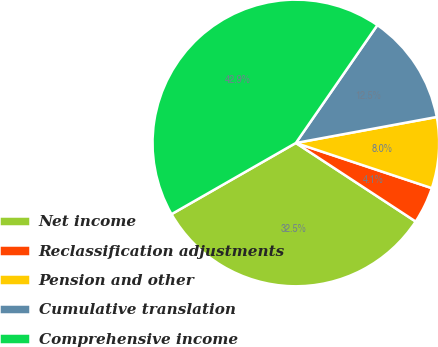Convert chart. <chart><loc_0><loc_0><loc_500><loc_500><pie_chart><fcel>Net income<fcel>Reclassification adjustments<fcel>Pension and other<fcel>Cumulative translation<fcel>Comprehensive income<nl><fcel>32.49%<fcel>4.13%<fcel>8.01%<fcel>12.47%<fcel>42.91%<nl></chart> 